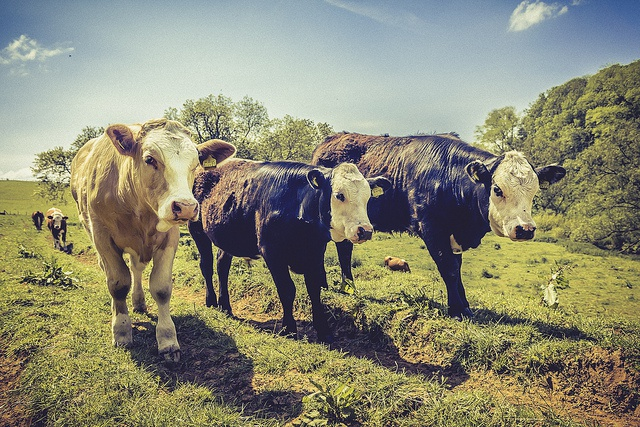Describe the objects in this image and their specific colors. I can see cow in blue, gray, tan, and khaki tones, cow in gray, black, navy, and tan tones, cow in blue, black, navy, gray, and tan tones, cow in gray, black, and tan tones, and cow in gray, black, and tan tones in this image. 